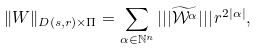<formula> <loc_0><loc_0><loc_500><loc_500>\| W \| _ { D ( s , r ) \times \Pi } = \sum _ { \alpha \in \mathbb { N } ^ { n } } | | | \widetilde { \mathcal { W } ^ { \alpha } } | | | \, r ^ { 2 | \alpha | } ,</formula> 